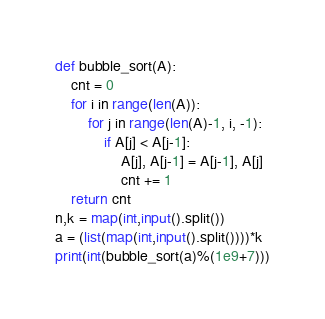<code> <loc_0><loc_0><loc_500><loc_500><_Python_>def bubble_sort(A):
    cnt = 0
    for i in range(len(A)):
        for j in range(len(A)-1, i, -1):
            if A[j] < A[j-1]:
                A[j], A[j-1] = A[j-1], A[j]
                cnt += 1
    return cnt
n,k = map(int,input().split())
a = (list(map(int,input().split())))*k
print(int(bubble_sort(a)%(1e9+7)))
</code> 